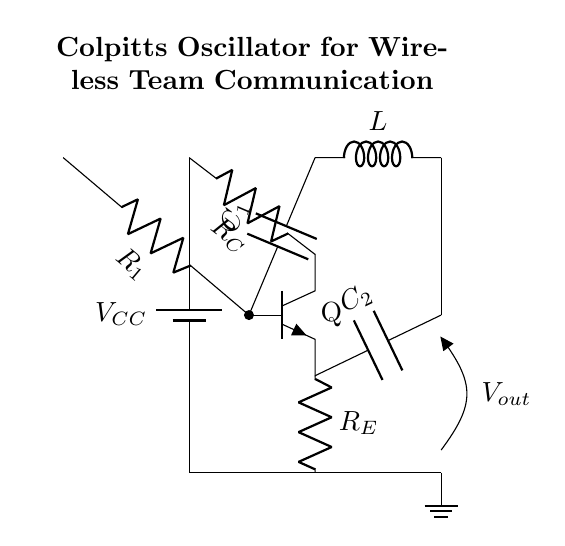What is the voltage supply in this circuit? The circuit specifies a supply voltage indicated by the battery symbol with the label V_CC, which typically denotes the power source for the oscillator circuit.
Answer: V_CC What type of transistor is used in this circuit? The symbol for the transistor is labeled as Q and represents an NPN transistor. It can be identified by the arrow on the emitter pointing outward.
Answer: NPN What are the values of C1 and C2? The circuit diagram represents the capacitors with labels C1 and C2 but does not specify their numerical values directly in the diagram. In context, these are crucial for defining the oscillator frequency but are unlabeled with specific values.
Answer: Not specified What is the purpose of resistor R1? R1 is connected to the base of the NPN transistor, providing the necessary biasing current for the transistor to operate in the active region, which is critical for oscillator functioning.
Answer: Biasing What connects the collector and emitter of the transistor? The collector C of the NPN transistor is connected to R_C and then to the voltage supply while the emitter E is connected to R_E and the ground, establishing a feedback loop essential for oscillation.
Answer: Feedback loop How does this circuit generate oscillation? The Colpitts oscillator generates oscillation through a tank circuit arrangement using the inductors L and capacitors C1 and C2, whereby the feedback provided by the divided voltage across C1 and C2 sustains the oscillation process in conjunction with the transistor's amplification.
Answer: Tank circuit feedback 